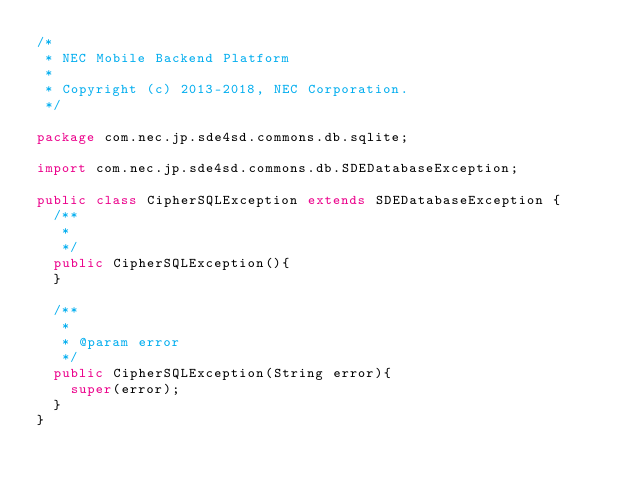Convert code to text. <code><loc_0><loc_0><loc_500><loc_500><_Java_>/*
 * NEC Mobile Backend Platform
 *
 * Copyright (c) 2013-2018, NEC Corporation.
 */

package com.nec.jp.sde4sd.commons.db.sqlite;

import com.nec.jp.sde4sd.commons.db.SDEDatabaseException;

public class CipherSQLException extends SDEDatabaseException {
	/**
	 * 
	 */
	public CipherSQLException(){
	}
	
	/**
	 * 
	 * @param error
	 */
	public CipherSQLException(String error){
		super(error);
	}
}
</code> 